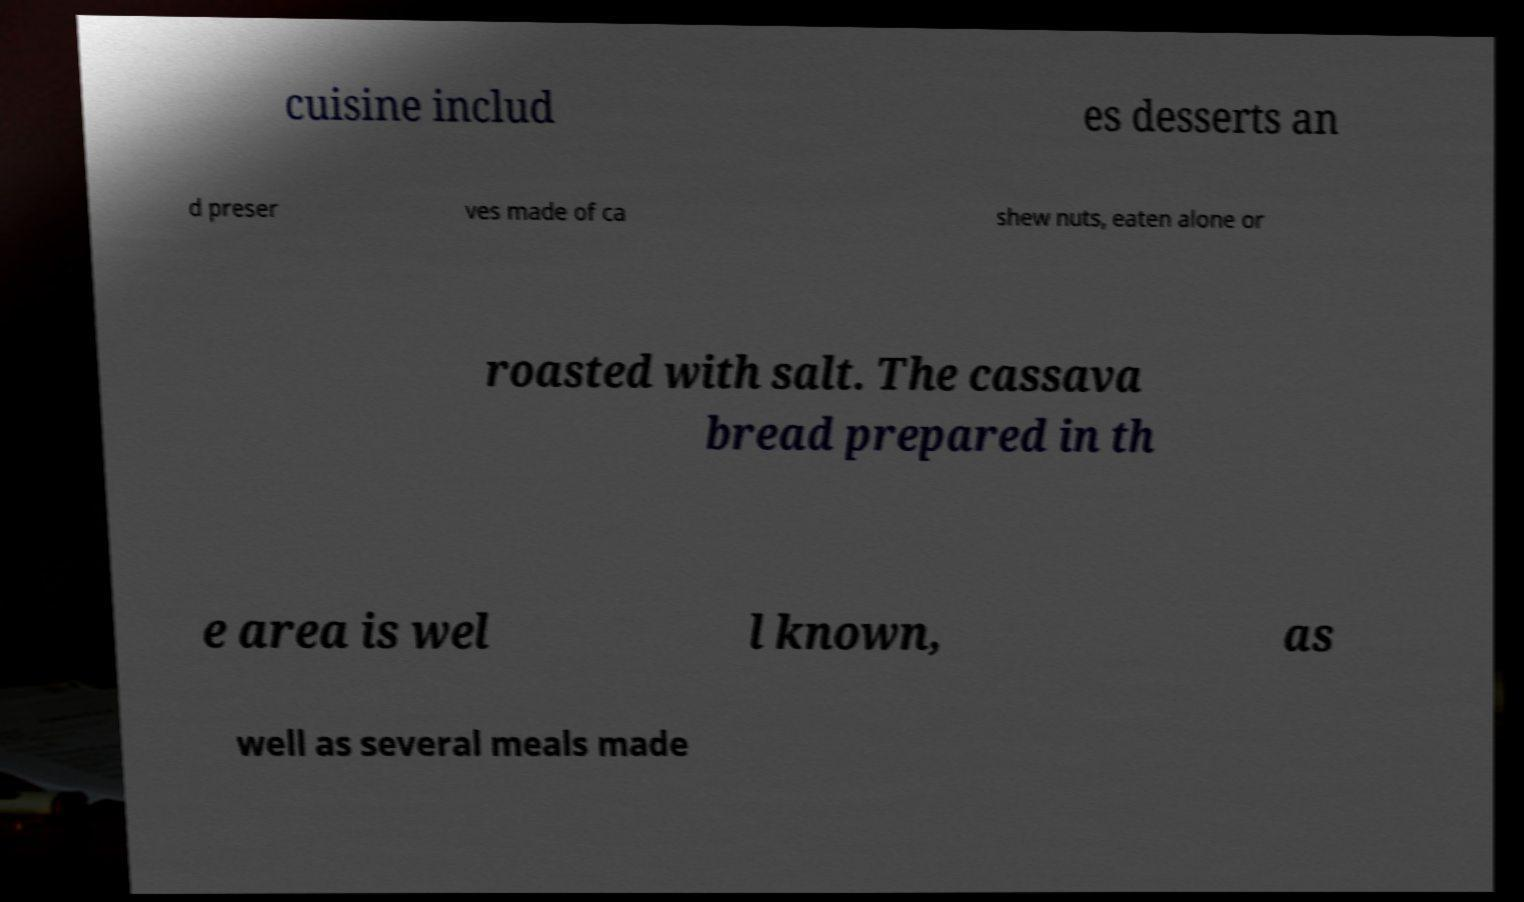Please read and relay the text visible in this image. What does it say? cuisine includ es desserts an d preser ves made of ca shew nuts, eaten alone or roasted with salt. The cassava bread prepared in th e area is wel l known, as well as several meals made 